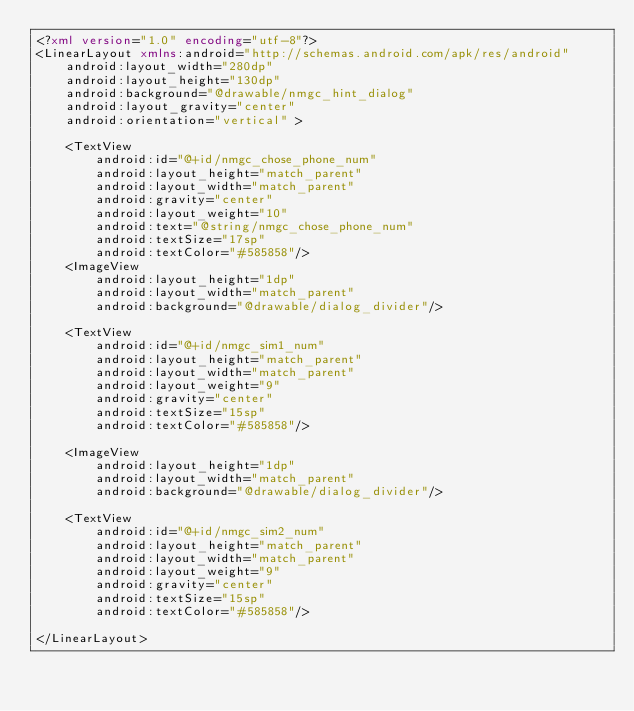Convert code to text. <code><loc_0><loc_0><loc_500><loc_500><_XML_><?xml version="1.0" encoding="utf-8"?>
<LinearLayout xmlns:android="http://schemas.android.com/apk/res/android"
    android:layout_width="280dp"
    android:layout_height="130dp"
    android:background="@drawable/nmgc_hint_dialog"
    android:layout_gravity="center"
    android:orientation="vertical" >
    
    <TextView 
        android:id="@+id/nmgc_chose_phone_num"
        android:layout_height="match_parent"
        android:layout_width="match_parent"   	
        android:gravity="center"
        android:layout_weight="10"
        android:text="@string/nmgc_chose_phone_num"
        android:textSize="17sp"
        android:textColor="#585858"/>
    <ImageView 
        android:layout_height="1dp"
        android:layout_width="match_parent"
        android:background="@drawable/dialog_divider"/>
    
    <TextView 
        android:id="@+id/nmgc_sim1_num"
        android:layout_height="match_parent"
        android:layout_width="match_parent"
        android:layout_weight="9"
        android:gravity="center"
        android:textSize="15sp"
        android:textColor="#585858"/>
    
    <ImageView 
        android:layout_height="1dp"
        android:layout_width="match_parent"
        android:background="@drawable/dialog_divider"/>
    
    <TextView 
        android:id="@+id/nmgc_sim2_num"
        android:layout_height="match_parent"
        android:layout_width="match_parent"
        android:layout_weight="9"
        android:gravity="center"
        android:textSize="15sp"
        android:textColor="#585858"/>

</LinearLayout></code> 